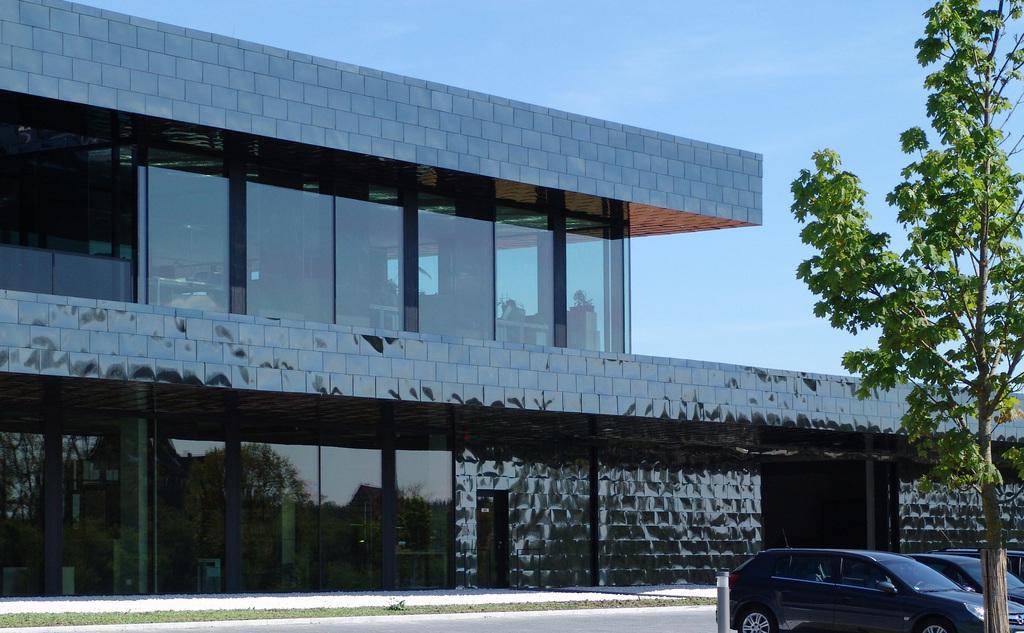In one or two sentences, can you explain what this image depicts? In the picture there is a building, there are glass walls present, there are cars, there is a tree, there is a clear sky. 